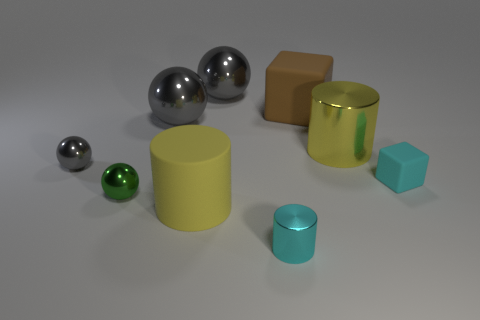What types of geometrical shapes are present in the image? The image features a variety of geometric shapes including spheres, a cube, a cuboid, and cylinders. Do the objects share any common features, apart from their geometry? Apart from their geometry, the objects share a smooth surface texture and reflective properties, suggesting they might be made from similar materials like plastic or polished metal. 